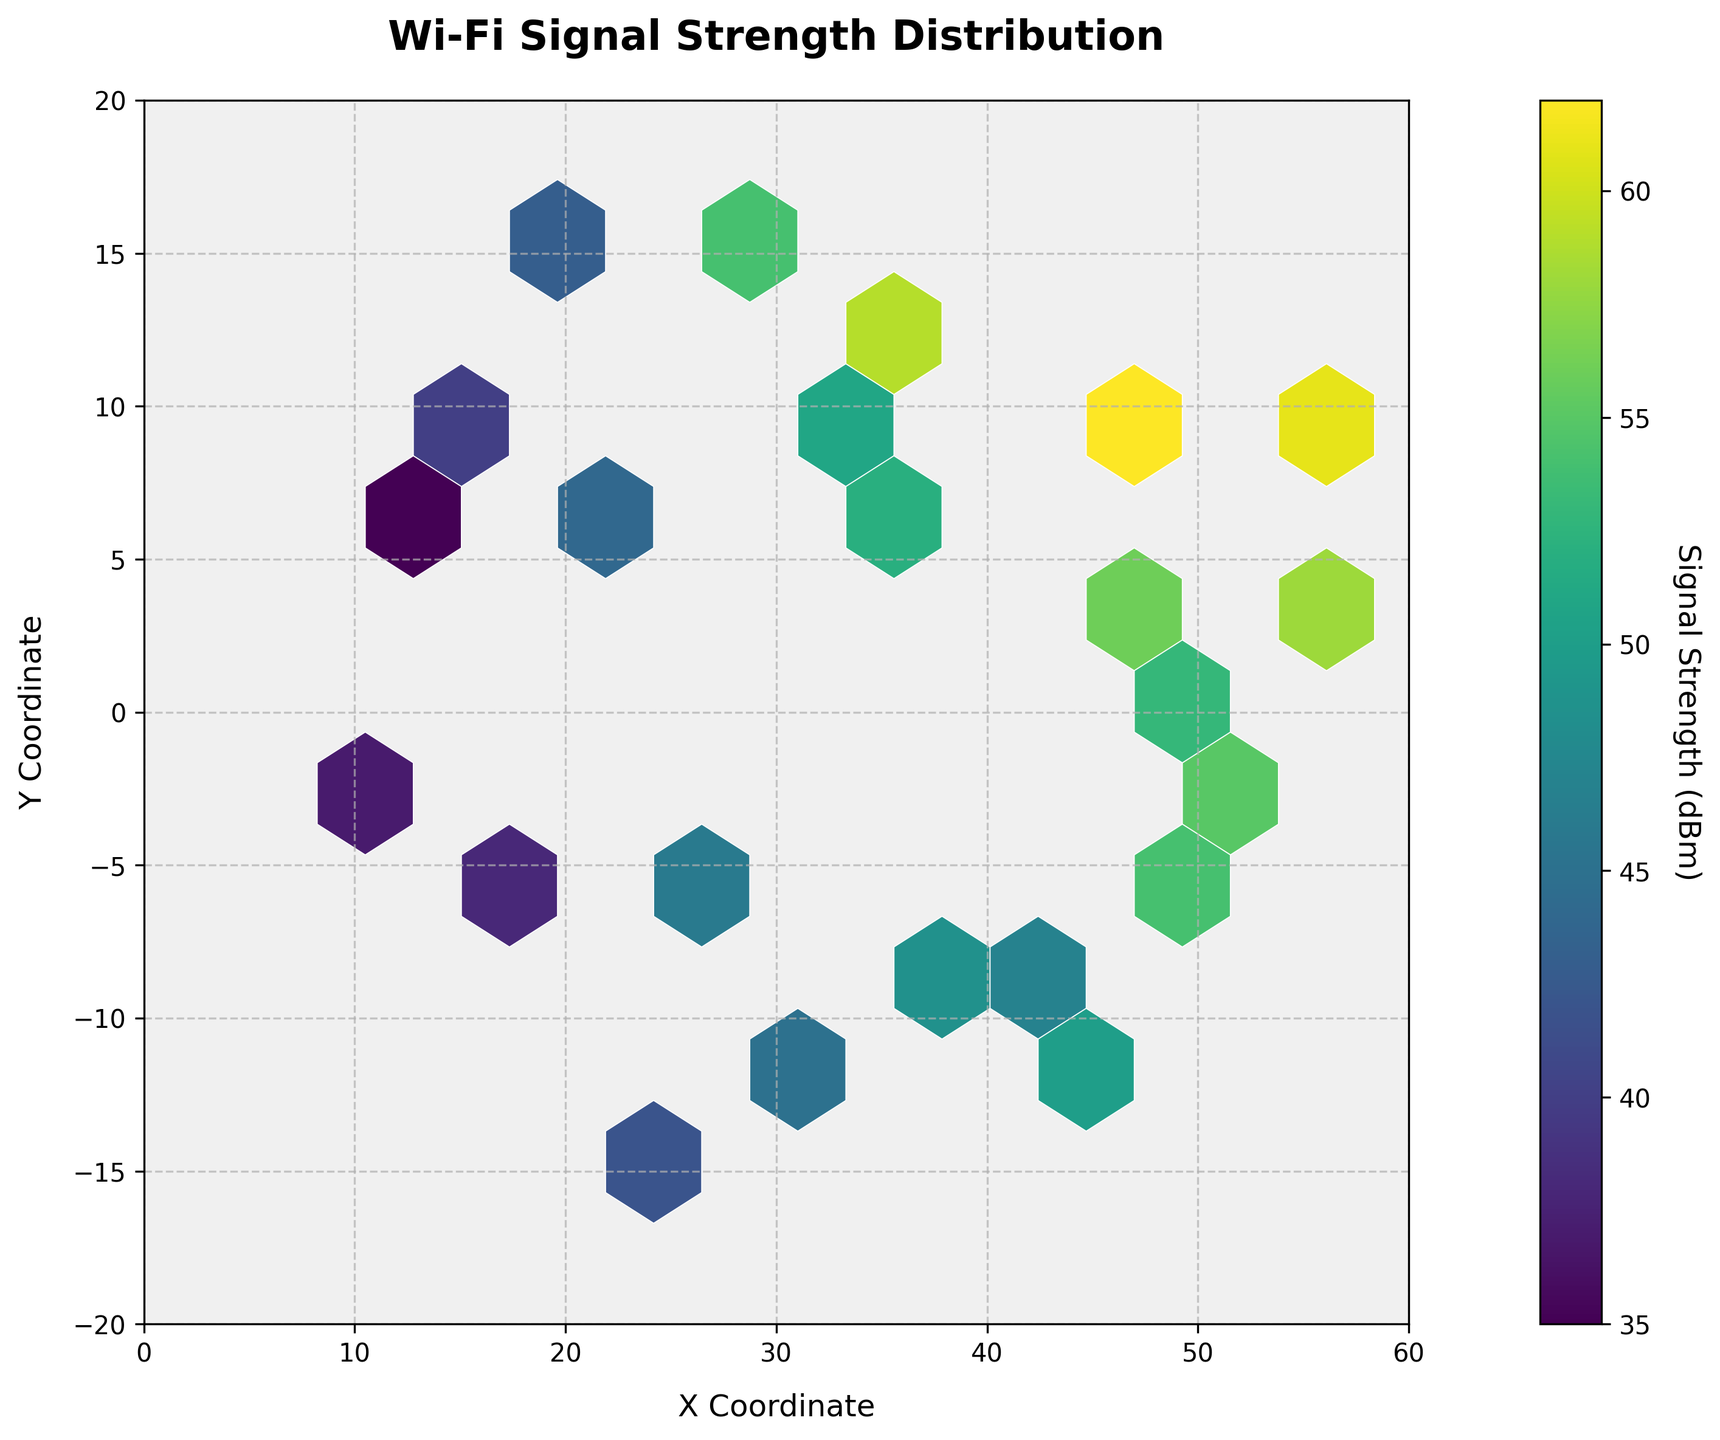What is the title of the hexbin plot? The title of the hexbin plot is displayed at the top, describing the content of the plot.
Answer: Wi-Fi Signal Strength Distribution What are the x and y axis labels on the plot? The labels are located along the respective axes of the plot, indicating what each axis represents.
Answer: X Coordinate (x-axis), Y Coordinate (y-axis) What is the color bar label on the plot? The color bar label is shown next to the color bar, explaining what the color intensity represents.
Answer: Signal Strength (dBm) How are the hexagons colored in the hexbin plot? The hexagons in the plot are color-coded according to the color bar, with a gradient that represents different levels of signal strength.
Answer: A gradient from purple to yellow (viridis color map) What range of values does the x-axis cover? The x-axis limits are defined at the bottom of the plot, showing the minimum and maximum x coordinates.
Answer: From 0 to 60 What range of values does the y-axis cover? The y-axis limits are defined along the side of the plot, showing the minimum and maximum y coordinates.
Answer: From -20 to 20 Which area has the highest Wi-Fi signal strength? The highest signal strength is indicated by the brightest (most yellow) hexagons on the plot. These hexagons are found around a specific x and y coordinate.
Answer: Around (45, 10) Is there any noticeable pattern in signal strength distribution across different locations? By observing the color gradient and the distribution of bright and dark hexagons, one can deduce if there is any visible pattern.
Answer: Higher signal strength clusters are around the central region Are there more areas with high signal strength or low signal strength? Comparing the number of dark hexagons to the number of bright hexagons will reveal if there are more areas with high or low signal strength.
Answer: More areas have lower signal strength How is signal strength distributed along the y-axis when x is around 20 to 40? By focusing on the region where x-coordinates are between 20 and 40 and observing the color of hexagons at different y-values, the distribution can be inferred.
Answer: Signal strength varies, with some high-strength clusters and many low-strength areas What is the average signal strength in the central region (x between 20 and 40, y between -10 and 10)? To find the average, observe the hexagons in the given region and interpret the color intensity based on the color bar to estimate the average signal strength.
Answer: Around 45-50 